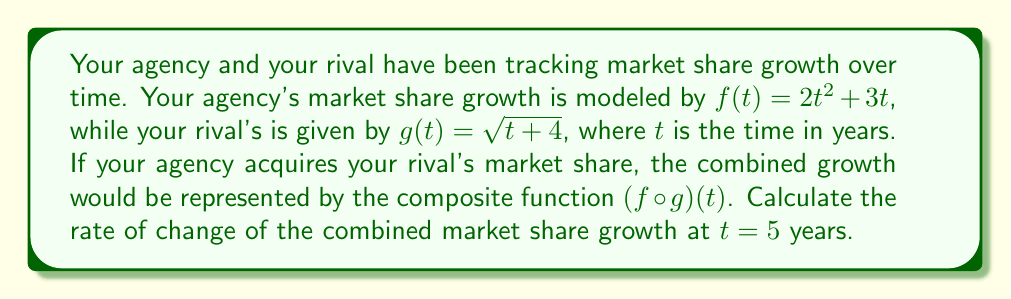What is the answer to this math problem? To solve this problem, we need to follow these steps:

1) First, let's form the composite function $(f \circ g)(t)$:
   $$(f \circ g)(t) = f(g(t)) = 2(\sqrt{t+4})^2 + 3(\sqrt{t+4})$$

2) Simplify the composite function:
   $$(f \circ g)(t) = 2(t+4) + 3\sqrt{t+4} = 2t + 8 + 3\sqrt{t+4}$$

3) To find the rate of change at $t = 5$, we need to differentiate $(f \circ g)(t)$ with respect to $t$:
   $$\frac{d}{dt}(f \circ g)(t) = 2 + \frac{3}{2\sqrt{t+4}}$$

4) Now, we evaluate this derivative at $t = 5$:
   $$\frac{d}{dt}(f \circ g)(5) = 2 + \frac{3}{2\sqrt{5+4}} = 2 + \frac{3}{2\sqrt{9}} = 2 + \frac{3}{2 \cdot 3} = 2 + \frac{1}{2} = \frac{5}{2}$$

The rate of change at $t = 5$ years is $\frac{5}{2}$ or 2.5 units per year.
Answer: $\frac{5}{2}$ or 2.5 units per year 